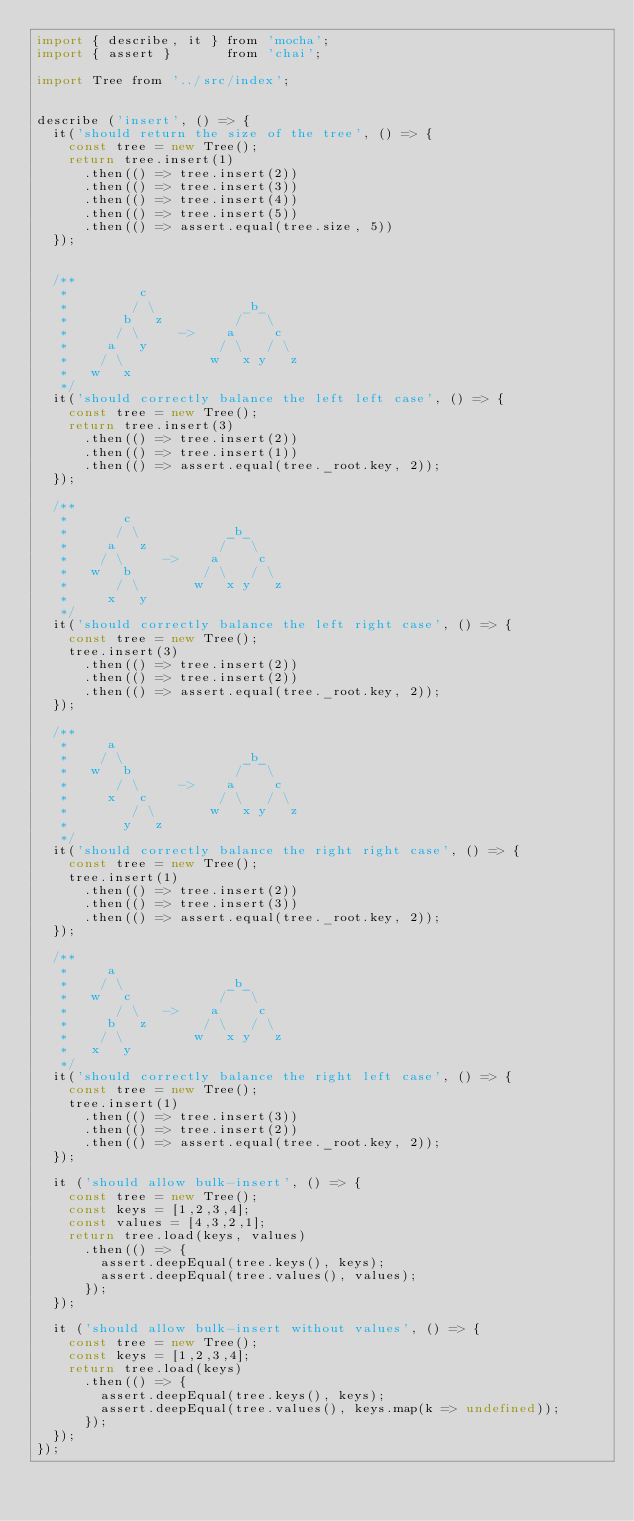<code> <loc_0><loc_0><loc_500><loc_500><_JavaScript_>import { describe, it } from 'mocha';
import { assert }       from 'chai';

import Tree from '../src/index';


describe ('insert', () => {
  it('should return the size of the tree', () => {
    const tree = new Tree();
    return tree.insert(1)
      .then(() => tree.insert(2))
      .then(() => tree.insert(3))
      .then(() => tree.insert(4))
      .then(() => tree.insert(5))
      .then(() => assert.equal(tree.size, 5))
  });


  /**
   *         c
   *        / \           _b_
   *       b   z         /   \
   *      / \     ->    a     c
   *     a   y         / \   / \
   *    / \           w   x y   z
   *   w   x
   */
  it('should correctly balance the left left case', () => {
    const tree = new Tree();
    return tree.insert(3)
      .then(() => tree.insert(2))
      .then(() => tree.insert(1))
      .then(() => assert.equal(tree._root.key, 2));
  });

  /**
   *       c
   *      / \           _b_
   *     a   z         /   \
   *    / \     ->    a     c
   *   w   b         / \   / \
   *      / \       w   x y   z
   *     x   y
   */
  it('should correctly balance the left right case', () => {
    const tree = new Tree();
    tree.insert(3)
      .then(() => tree.insert(2))
      .then(() => tree.insert(2))
      .then(() => assert.equal(tree._root.key, 2));
  });

  /**
   *     a
   *    / \               _b_
   *   w   b             /   \
   *      / \     ->    a     c
   *     x   c         / \   / \
   *        / \       w   x y   z
   *       y   z
   */
  it('should correctly balance the right right case', () => {
    const tree = new Tree();
    tree.insert(1)
      .then(() => tree.insert(2))
      .then(() => tree.insert(3))
      .then(() => assert.equal(tree._root.key, 2));
  });

  /**
   *     a
   *    / \             _b_
   *   w   c           /   \
   *      / \   ->    a     c
   *     b   z       / \   / \
   *    / \         w   x y   z
   *   x   y
   */
  it('should correctly balance the right left case', () => {
    const tree = new Tree();
    tree.insert(1)
      .then(() => tree.insert(3))
      .then(() => tree.insert(2))
      .then(() => assert.equal(tree._root.key, 2));
  });

  it ('should allow bulk-insert', () => {
    const tree = new Tree();
    const keys = [1,2,3,4];
    const values = [4,3,2,1];
    return tree.load(keys, values)
      .then(() => {
        assert.deepEqual(tree.keys(), keys);
        assert.deepEqual(tree.values(), values);
      });
  });

  it ('should allow bulk-insert without values', () => {
    const tree = new Tree();
    const keys = [1,2,3,4];
    return tree.load(keys)
      .then(() => {
        assert.deepEqual(tree.keys(), keys);
        assert.deepEqual(tree.values(), keys.map(k => undefined));
      });
  });
});
</code> 